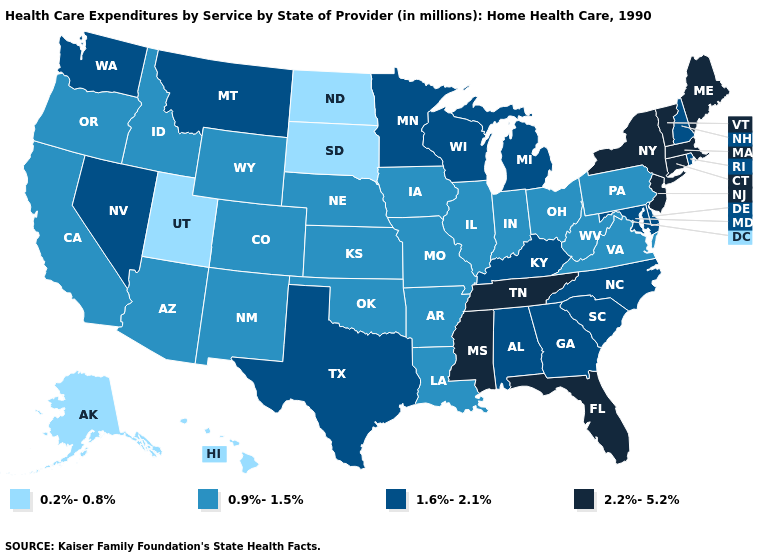Among the states that border Montana , which have the lowest value?
Give a very brief answer. North Dakota, South Dakota. Among the states that border New Mexico , does Texas have the highest value?
Short answer required. Yes. Does Alaska have the lowest value in the USA?
Give a very brief answer. Yes. Among the states that border Virginia , which have the highest value?
Keep it brief. Tennessee. Name the states that have a value in the range 0.9%-1.5%?
Be succinct. Arizona, Arkansas, California, Colorado, Idaho, Illinois, Indiana, Iowa, Kansas, Louisiana, Missouri, Nebraska, New Mexico, Ohio, Oklahoma, Oregon, Pennsylvania, Virginia, West Virginia, Wyoming. Does Hawaii have the highest value in the West?
Concise answer only. No. Name the states that have a value in the range 1.6%-2.1%?
Short answer required. Alabama, Delaware, Georgia, Kentucky, Maryland, Michigan, Minnesota, Montana, Nevada, New Hampshire, North Carolina, Rhode Island, South Carolina, Texas, Washington, Wisconsin. Does Rhode Island have the same value as Michigan?
Keep it brief. Yes. What is the lowest value in the USA?
Write a very short answer. 0.2%-0.8%. What is the value of Oklahoma?
Keep it brief. 0.9%-1.5%. What is the lowest value in states that border California?
Answer briefly. 0.9%-1.5%. What is the value of New York?
Give a very brief answer. 2.2%-5.2%. What is the value of Iowa?
Give a very brief answer. 0.9%-1.5%. Name the states that have a value in the range 2.2%-5.2%?
Give a very brief answer. Connecticut, Florida, Maine, Massachusetts, Mississippi, New Jersey, New York, Tennessee, Vermont. Name the states that have a value in the range 2.2%-5.2%?
Give a very brief answer. Connecticut, Florida, Maine, Massachusetts, Mississippi, New Jersey, New York, Tennessee, Vermont. 